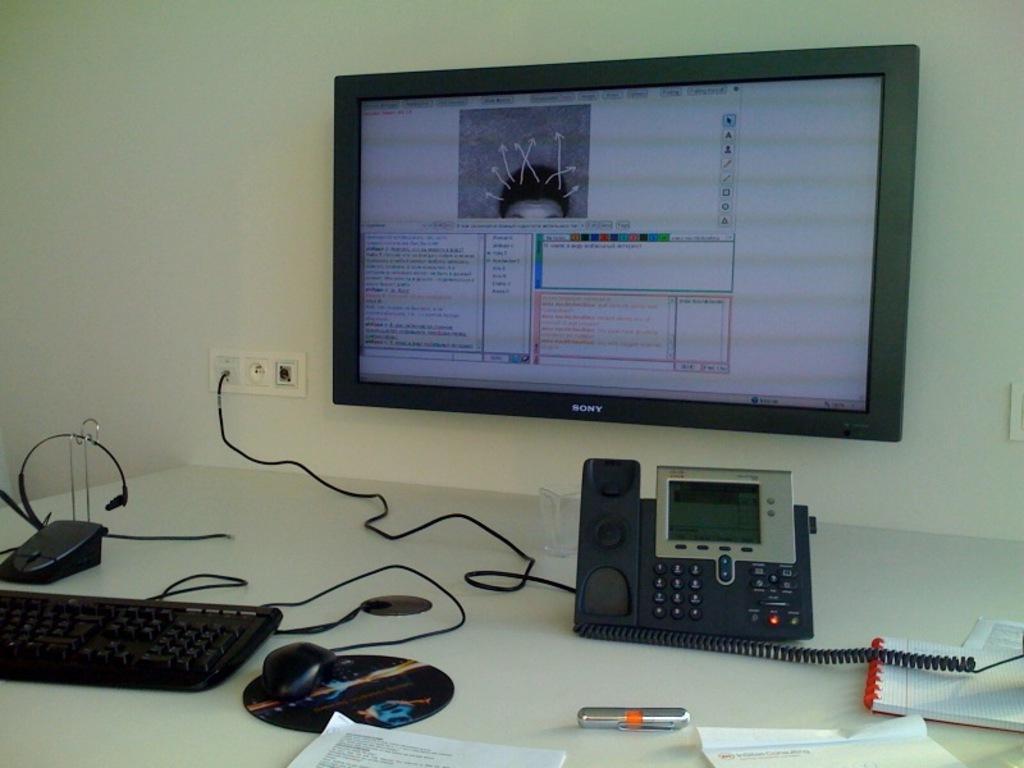In one or two sentences, can you explain what this image depicts? This image is taken inside a room. In this image there is a wall with and a screen on it with text and a switch board. In this image there is a table with keyboard, headset, mouse, mouse pad, telephone and few papers on it. 